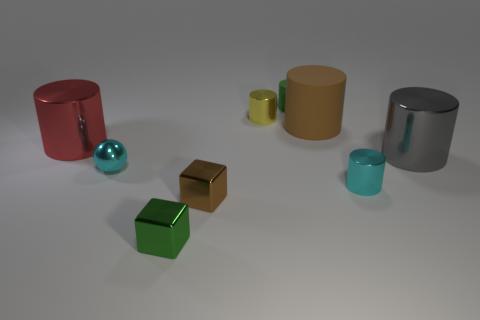Is there any other thing that is the same size as the green shiny cube?
Give a very brief answer. Yes. There is a shiny thing that is to the right of the yellow shiny cylinder and to the left of the gray thing; what size is it?
Provide a short and direct response. Small. There is a gray thing that is made of the same material as the small brown thing; what shape is it?
Your answer should be very brief. Cylinder. Are the small yellow cylinder and the tiny green object in front of the brown cylinder made of the same material?
Provide a succinct answer. Yes. There is a metal cube that is in front of the brown metallic object; are there any green metallic cubes left of it?
Your response must be concise. No. What material is the green thing that is the same shape as the small brown object?
Make the answer very short. Metal. There is a large thing left of the brown shiny cube; how many big gray cylinders are behind it?
Offer a very short reply. 0. Are there any other things that have the same color as the tiny metal sphere?
Your answer should be compact. Yes. What number of things are small shiny blocks or big things left of the brown matte cylinder?
Your response must be concise. 3. The brown thing behind the small cylinder in front of the big metallic thing behind the gray metal cylinder is made of what material?
Offer a terse response. Rubber. 